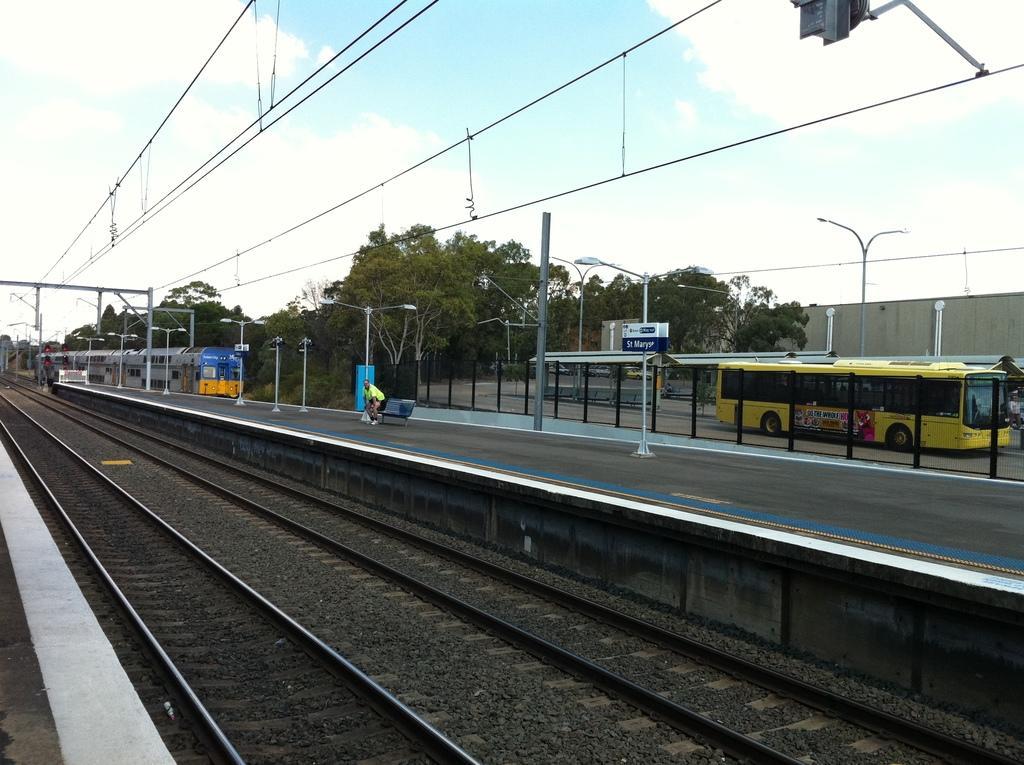Describe this image in one or two sentences. This image is clicked in a railway station. There are trees in the middle. There are railway tracks in the middle. There is a train on the left side. There is sky at the top. There is a bus on the right side. There are lights in the middle. There is a person sitting in the middle. 